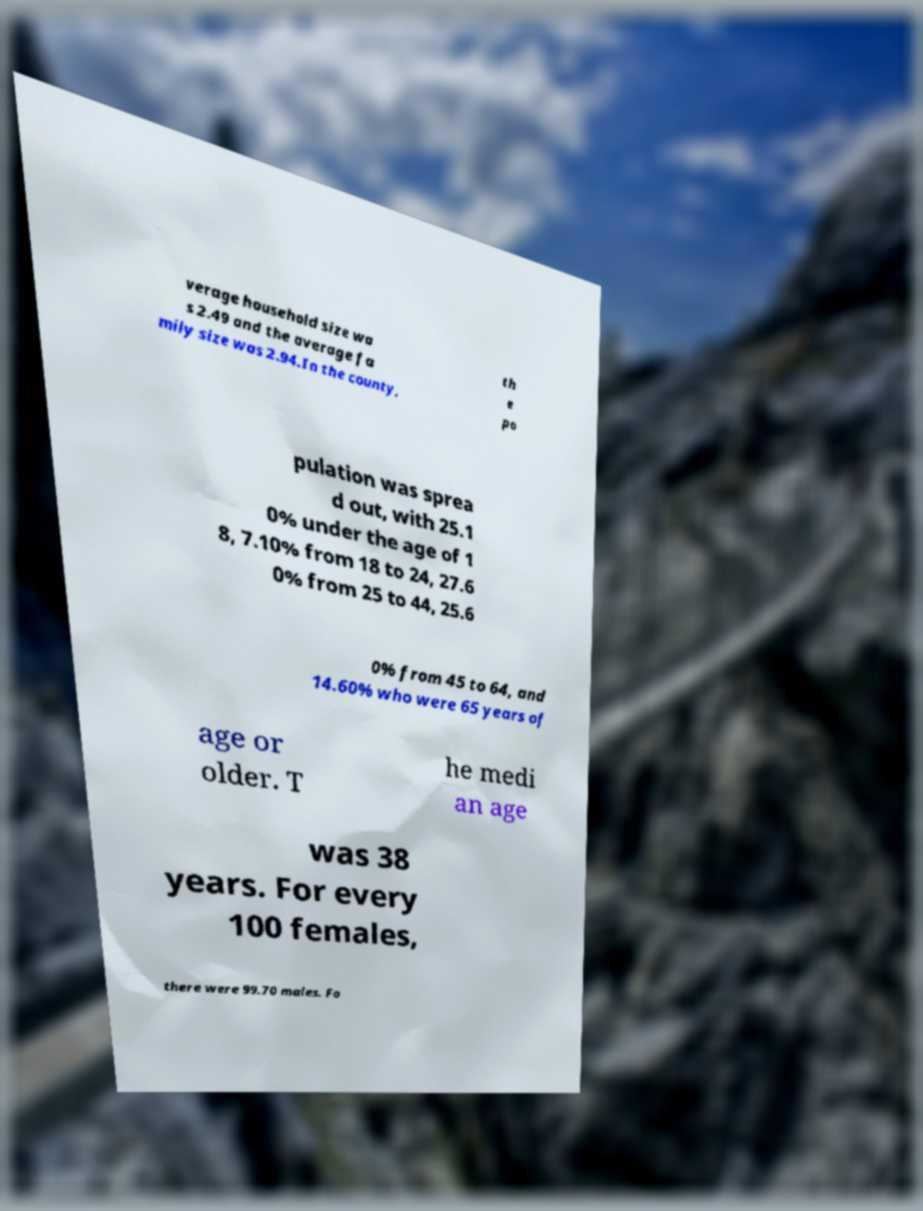For documentation purposes, I need the text within this image transcribed. Could you provide that? verage household size wa s 2.49 and the average fa mily size was 2.94.In the county, th e po pulation was sprea d out, with 25.1 0% under the age of 1 8, 7.10% from 18 to 24, 27.6 0% from 25 to 44, 25.6 0% from 45 to 64, and 14.60% who were 65 years of age or older. T he medi an age was 38 years. For every 100 females, there were 99.70 males. Fo 